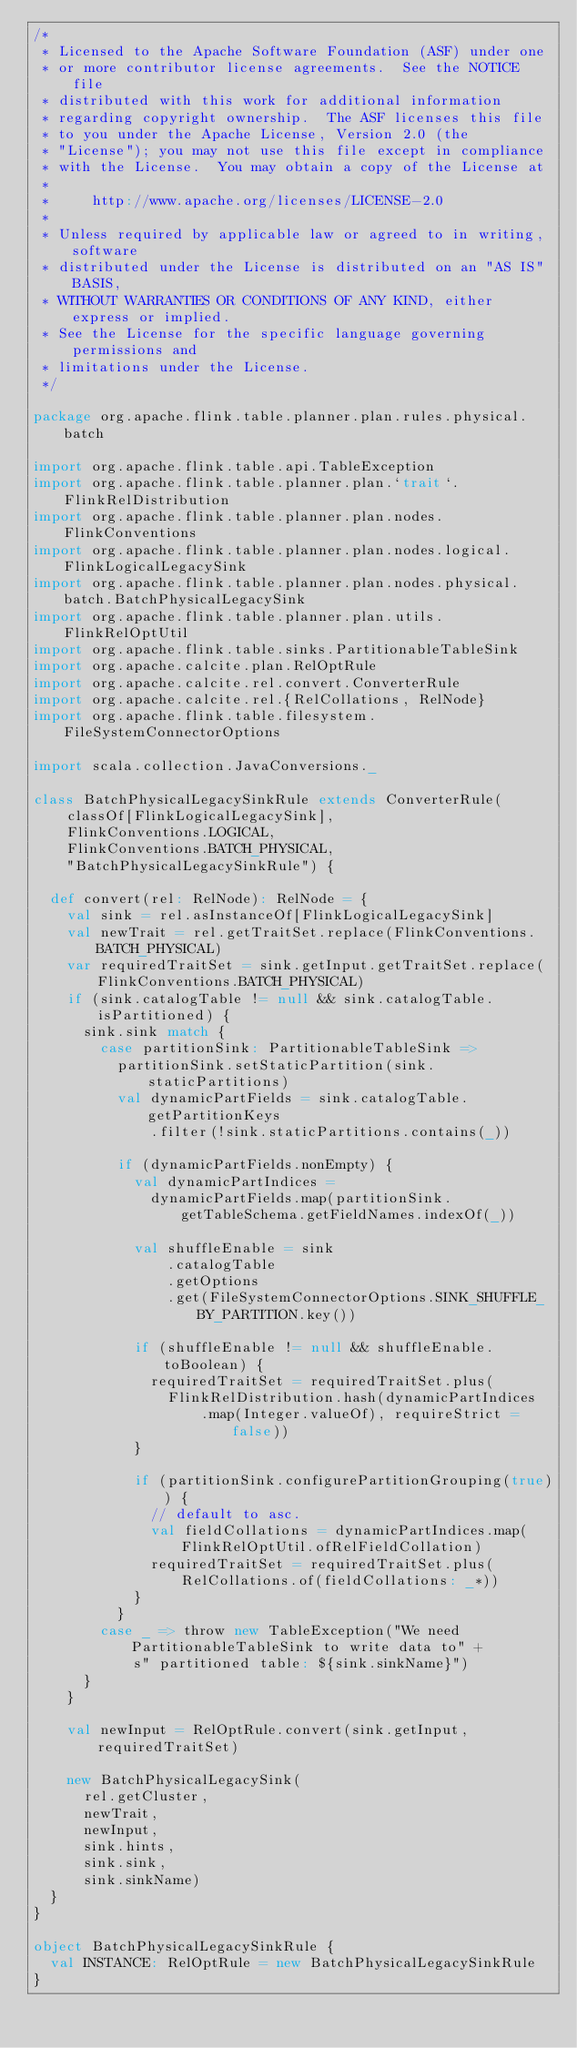<code> <loc_0><loc_0><loc_500><loc_500><_Scala_>/*
 * Licensed to the Apache Software Foundation (ASF) under one
 * or more contributor license agreements.  See the NOTICE file
 * distributed with this work for additional information
 * regarding copyright ownership.  The ASF licenses this file
 * to you under the Apache License, Version 2.0 (the
 * "License"); you may not use this file except in compliance
 * with the License.  You may obtain a copy of the License at
 *
 *     http://www.apache.org/licenses/LICENSE-2.0
 *
 * Unless required by applicable law or agreed to in writing, software
 * distributed under the License is distributed on an "AS IS" BASIS,
 * WITHOUT WARRANTIES OR CONDITIONS OF ANY KIND, either express or implied.
 * See the License for the specific language governing permissions and
 * limitations under the License.
 */

package org.apache.flink.table.planner.plan.rules.physical.batch

import org.apache.flink.table.api.TableException
import org.apache.flink.table.planner.plan.`trait`.FlinkRelDistribution
import org.apache.flink.table.planner.plan.nodes.FlinkConventions
import org.apache.flink.table.planner.plan.nodes.logical.FlinkLogicalLegacySink
import org.apache.flink.table.planner.plan.nodes.physical.batch.BatchPhysicalLegacySink
import org.apache.flink.table.planner.plan.utils.FlinkRelOptUtil
import org.apache.flink.table.sinks.PartitionableTableSink
import org.apache.calcite.plan.RelOptRule
import org.apache.calcite.rel.convert.ConverterRule
import org.apache.calcite.rel.{RelCollations, RelNode}
import org.apache.flink.table.filesystem.FileSystemConnectorOptions

import scala.collection.JavaConversions._

class BatchPhysicalLegacySinkRule extends ConverterRule(
    classOf[FlinkLogicalLegacySink],
    FlinkConventions.LOGICAL,
    FlinkConventions.BATCH_PHYSICAL,
    "BatchPhysicalLegacySinkRule") {

  def convert(rel: RelNode): RelNode = {
    val sink = rel.asInstanceOf[FlinkLogicalLegacySink]
    val newTrait = rel.getTraitSet.replace(FlinkConventions.BATCH_PHYSICAL)
    var requiredTraitSet = sink.getInput.getTraitSet.replace(FlinkConventions.BATCH_PHYSICAL)
    if (sink.catalogTable != null && sink.catalogTable.isPartitioned) {
      sink.sink match {
        case partitionSink: PartitionableTableSink =>
          partitionSink.setStaticPartition(sink.staticPartitions)
          val dynamicPartFields = sink.catalogTable.getPartitionKeys
              .filter(!sink.staticPartitions.contains(_))

          if (dynamicPartFields.nonEmpty) {
            val dynamicPartIndices =
              dynamicPartFields.map(partitionSink.getTableSchema.getFieldNames.indexOf(_))

            val shuffleEnable = sink
                .catalogTable
                .getOptions
                .get(FileSystemConnectorOptions.SINK_SHUFFLE_BY_PARTITION.key())

            if (shuffleEnable != null && shuffleEnable.toBoolean) {
              requiredTraitSet = requiredTraitSet.plus(
                FlinkRelDistribution.hash(dynamicPartIndices
                    .map(Integer.valueOf), requireStrict = false))
            }

            if (partitionSink.configurePartitionGrouping(true)) {
              // default to asc.
              val fieldCollations = dynamicPartIndices.map(FlinkRelOptUtil.ofRelFieldCollation)
              requiredTraitSet = requiredTraitSet.plus(RelCollations.of(fieldCollations: _*))
            }
          }
        case _ => throw new TableException("We need PartitionableTableSink to write data to" +
            s" partitioned table: ${sink.sinkName}")
      }
    }

    val newInput = RelOptRule.convert(sink.getInput, requiredTraitSet)

    new BatchPhysicalLegacySink(
      rel.getCluster,
      newTrait,
      newInput,
      sink.hints,
      sink.sink,
      sink.sinkName)
  }
}

object BatchPhysicalLegacySinkRule {
  val INSTANCE: RelOptRule = new BatchPhysicalLegacySinkRule
}
</code> 